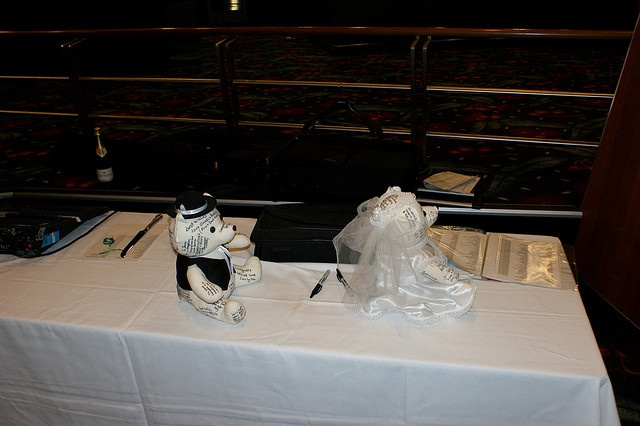Describe the objects in this image and their specific colors. I can see teddy bear in black, darkgray, lightgray, and gray tones, teddy bear in black, darkgray, lightgray, and gray tones, bottle in black, gray, and maroon tones, and knife in black, maroon, olive, and gray tones in this image. 